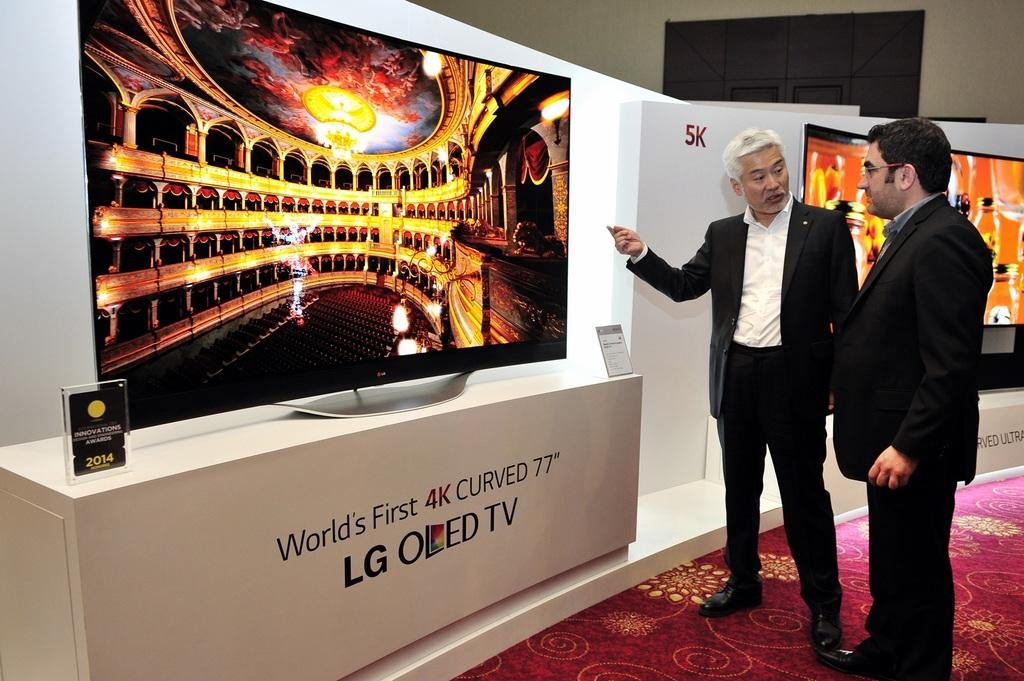<image>
Provide a brief description of the given image. Two men are standing in front of a display for the world's first 4k curved 77" tv. 